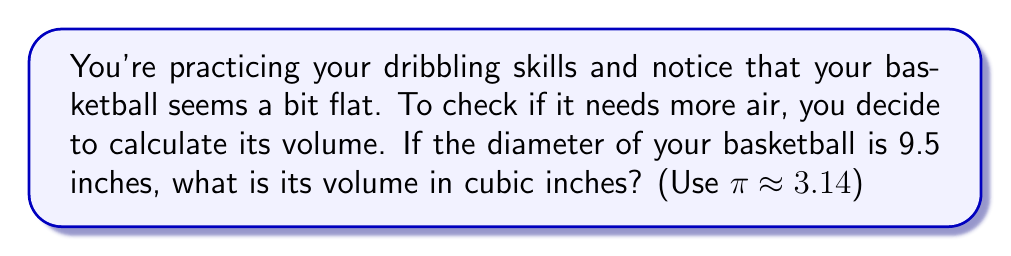Give your solution to this math problem. Let's approach this step-by-step:

1) A basketball is approximately spherical in shape. The volume of a sphere is given by the formula:

   $$V = \frac{4}{3}\pi r^3$$

   where $V$ is the volume and $r$ is the radius.

2) We're given the diameter, which is 9.5 inches. The radius is half of the diameter:

   $$r = \frac{9.5}{2} = 4.75\text{ inches}$$

3) Now, let's substitute this into our volume formula:

   $$V = \frac{4}{3}\pi (4.75)^3$$

4) Let's calculate this step-by-step:
   
   $$V = \frac{4}{3} \cdot 3.14 \cdot (4.75 \cdot 4.75 \cdot 4.75)$$
   $$V = \frac{4}{3} \cdot 3.14 \cdot 107.171875$$
   $$V = 4.18666667 \cdot 107.171875$$
   $$V = 448.69\text{ cubic inches}$$

5) Rounding to two decimal places:

   $$V \approx 448.69\text{ cubic inches}$$

This volume is close to the official NBA basketball volume, which is about 440 cubic inches, so your ball is likely properly inflated!
Answer: $448.69\text{ cubic inches}$ 